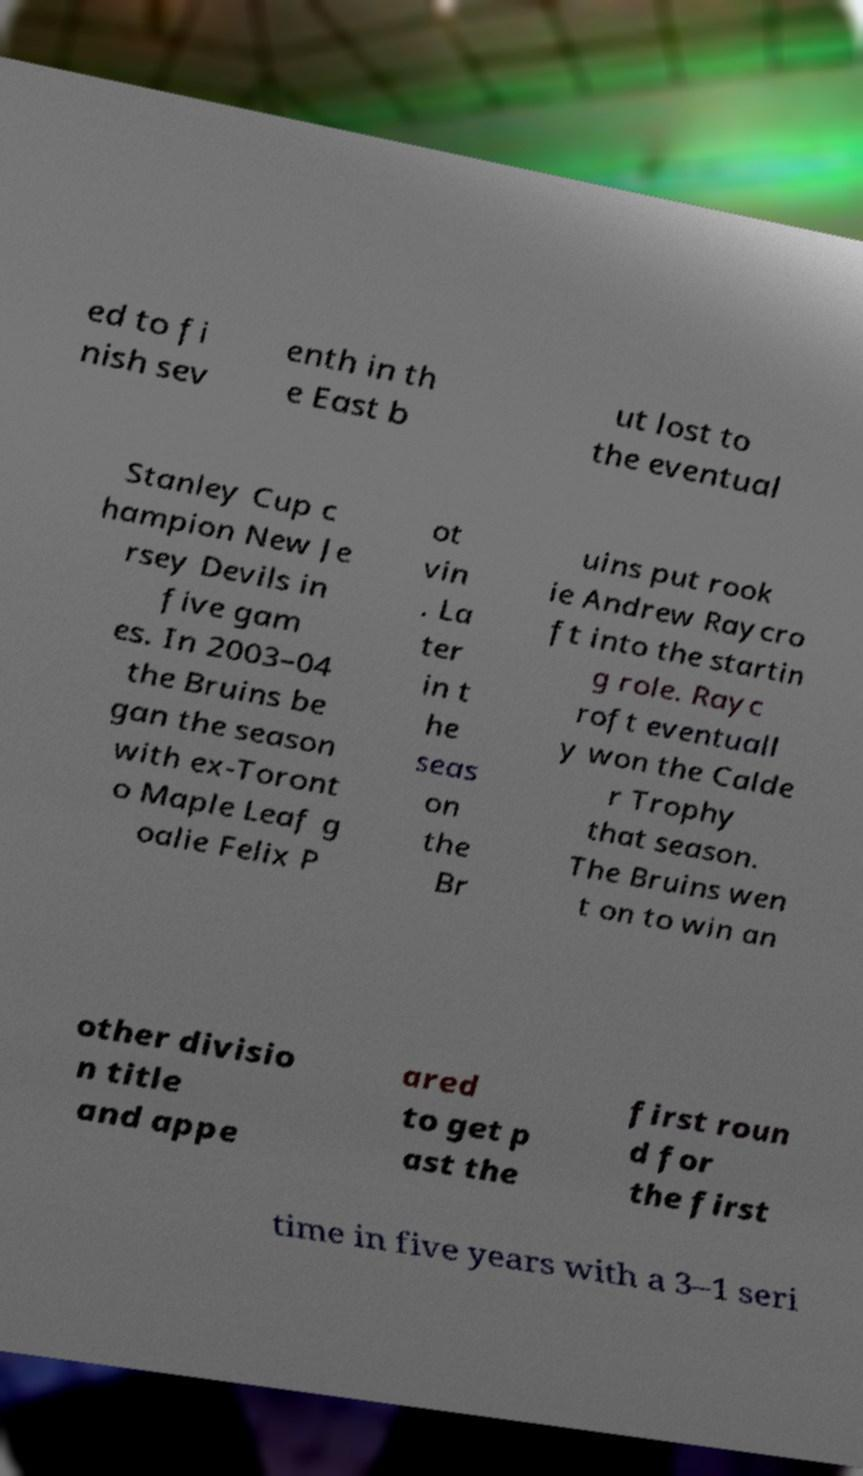Please identify and transcribe the text found in this image. ed to fi nish sev enth in th e East b ut lost to the eventual Stanley Cup c hampion New Je rsey Devils in five gam es. In 2003–04 the Bruins be gan the season with ex-Toront o Maple Leaf g oalie Felix P ot vin . La ter in t he seas on the Br uins put rook ie Andrew Raycro ft into the startin g role. Rayc roft eventuall y won the Calde r Trophy that season. The Bruins wen t on to win an other divisio n title and appe ared to get p ast the first roun d for the first time in five years with a 3–1 seri 